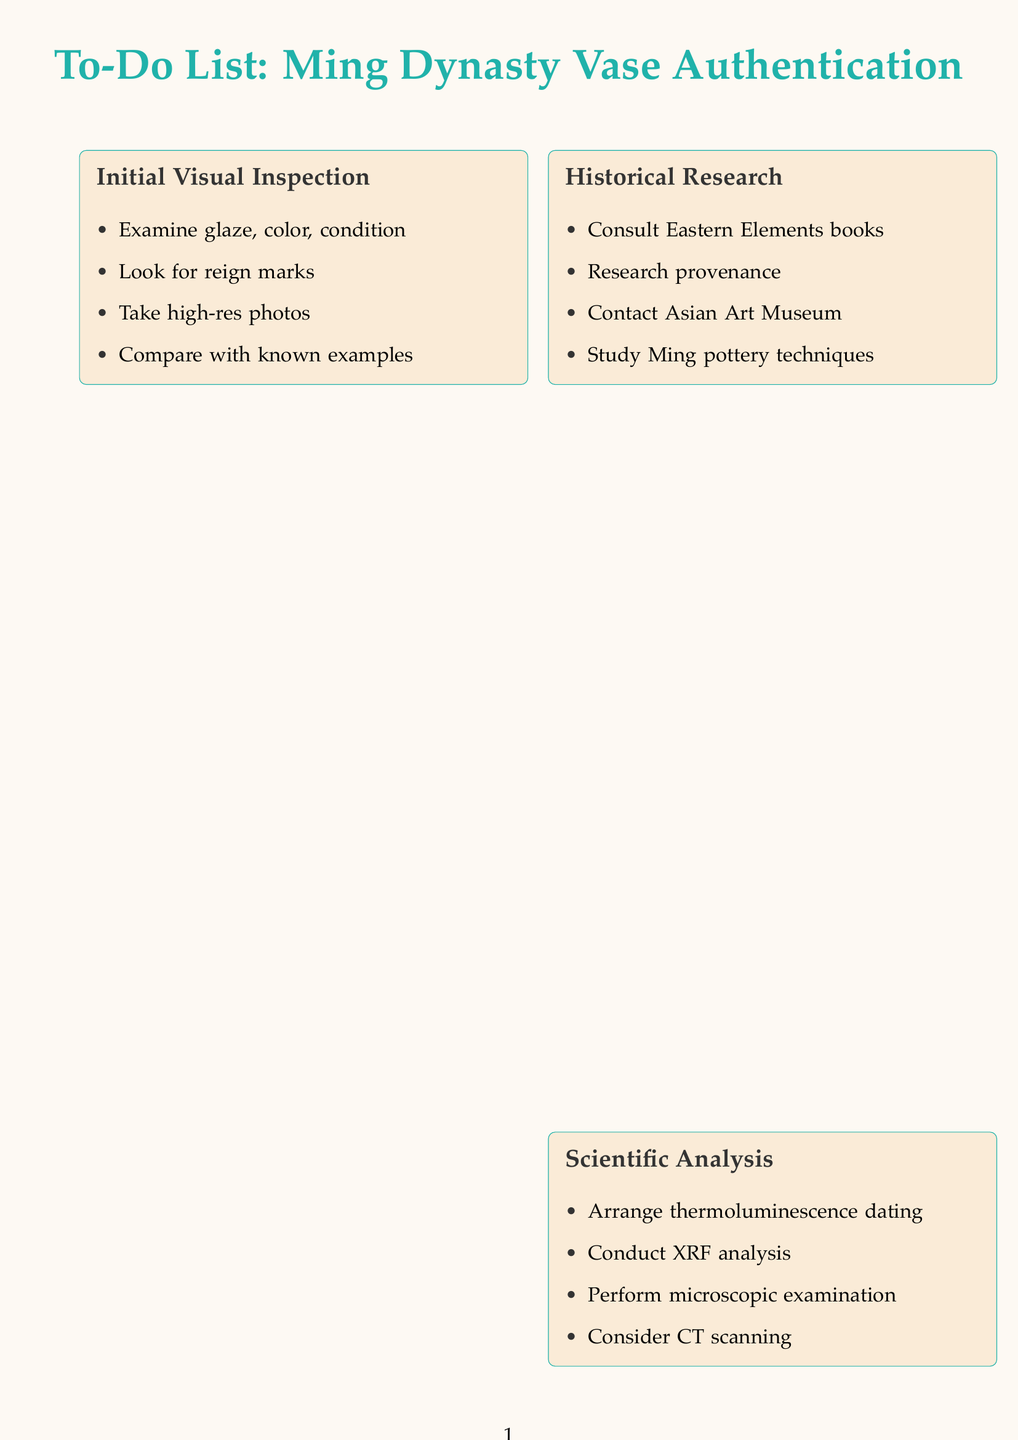What is the first task in the Initial Visual Inspection? The first task listed under Initial Visual Inspection is to examine the vase's glaze, color, and overall condition.
Answer: Examine the vase's glaze, color, and overall condition How many items are in the Authentication Documentation section? There are four tasks listed in the Authentication Documentation section.
Answer: Four Who is the renowned expert to be consulted? The document mentions Dr. Li Wei as the renowned expert for consultation.
Answer: Dr. Li Wei What type of analysis is suggested to determine glaze composition? The document suggests conducting X-ray fluorescence analysis for determining glaze composition.
Answer: X-ray fluorescence What is recommended for proper storage of the vase? The document recommends purchasing archival-quality materials for proper storage.
Answer: Archival-quality materials Which organization should the vase be registered with for added provenance security? The vase should be registered with the Art Loss Register for added provenance security.
Answer: Art Loss Register What is the purpose of the thermoluminescence dating? The purpose of thermoluminescence dating is to authenticate the vase by dating it scientifically.
Answer: Dating the vase scientifically How many sections are outlined in the to-do list? The to-do list outlines six distinct sections related to vase authentication.
Answer: Six 